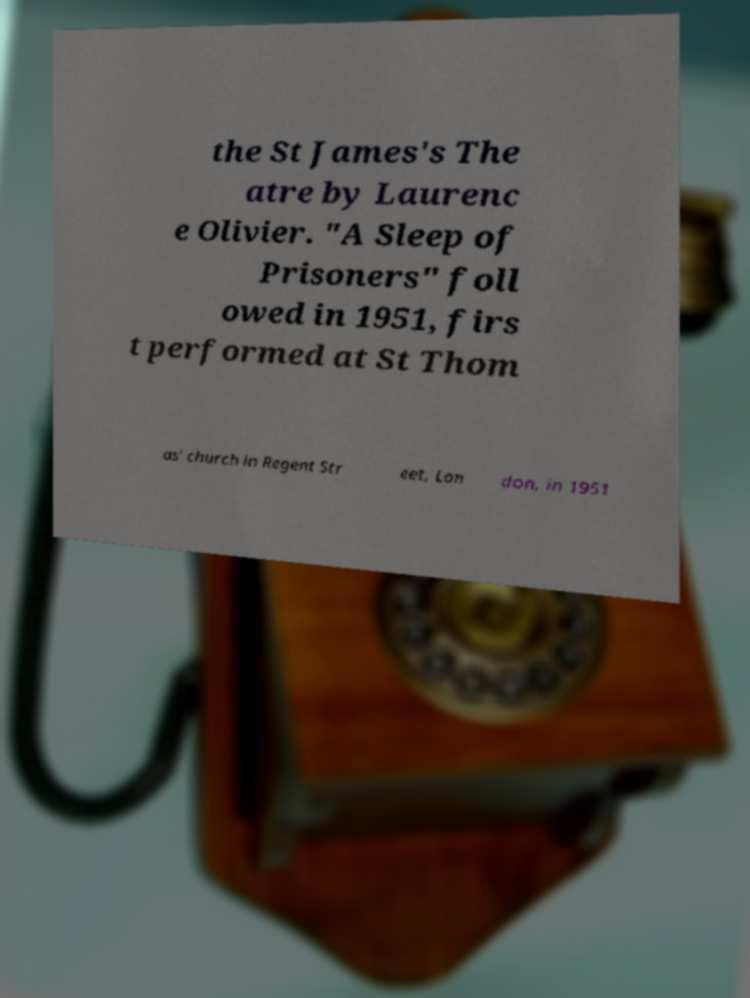Please identify and transcribe the text found in this image. the St James's The atre by Laurenc e Olivier. "A Sleep of Prisoners" foll owed in 1951, firs t performed at St Thom as' church in Regent Str eet, Lon don, in 1951 